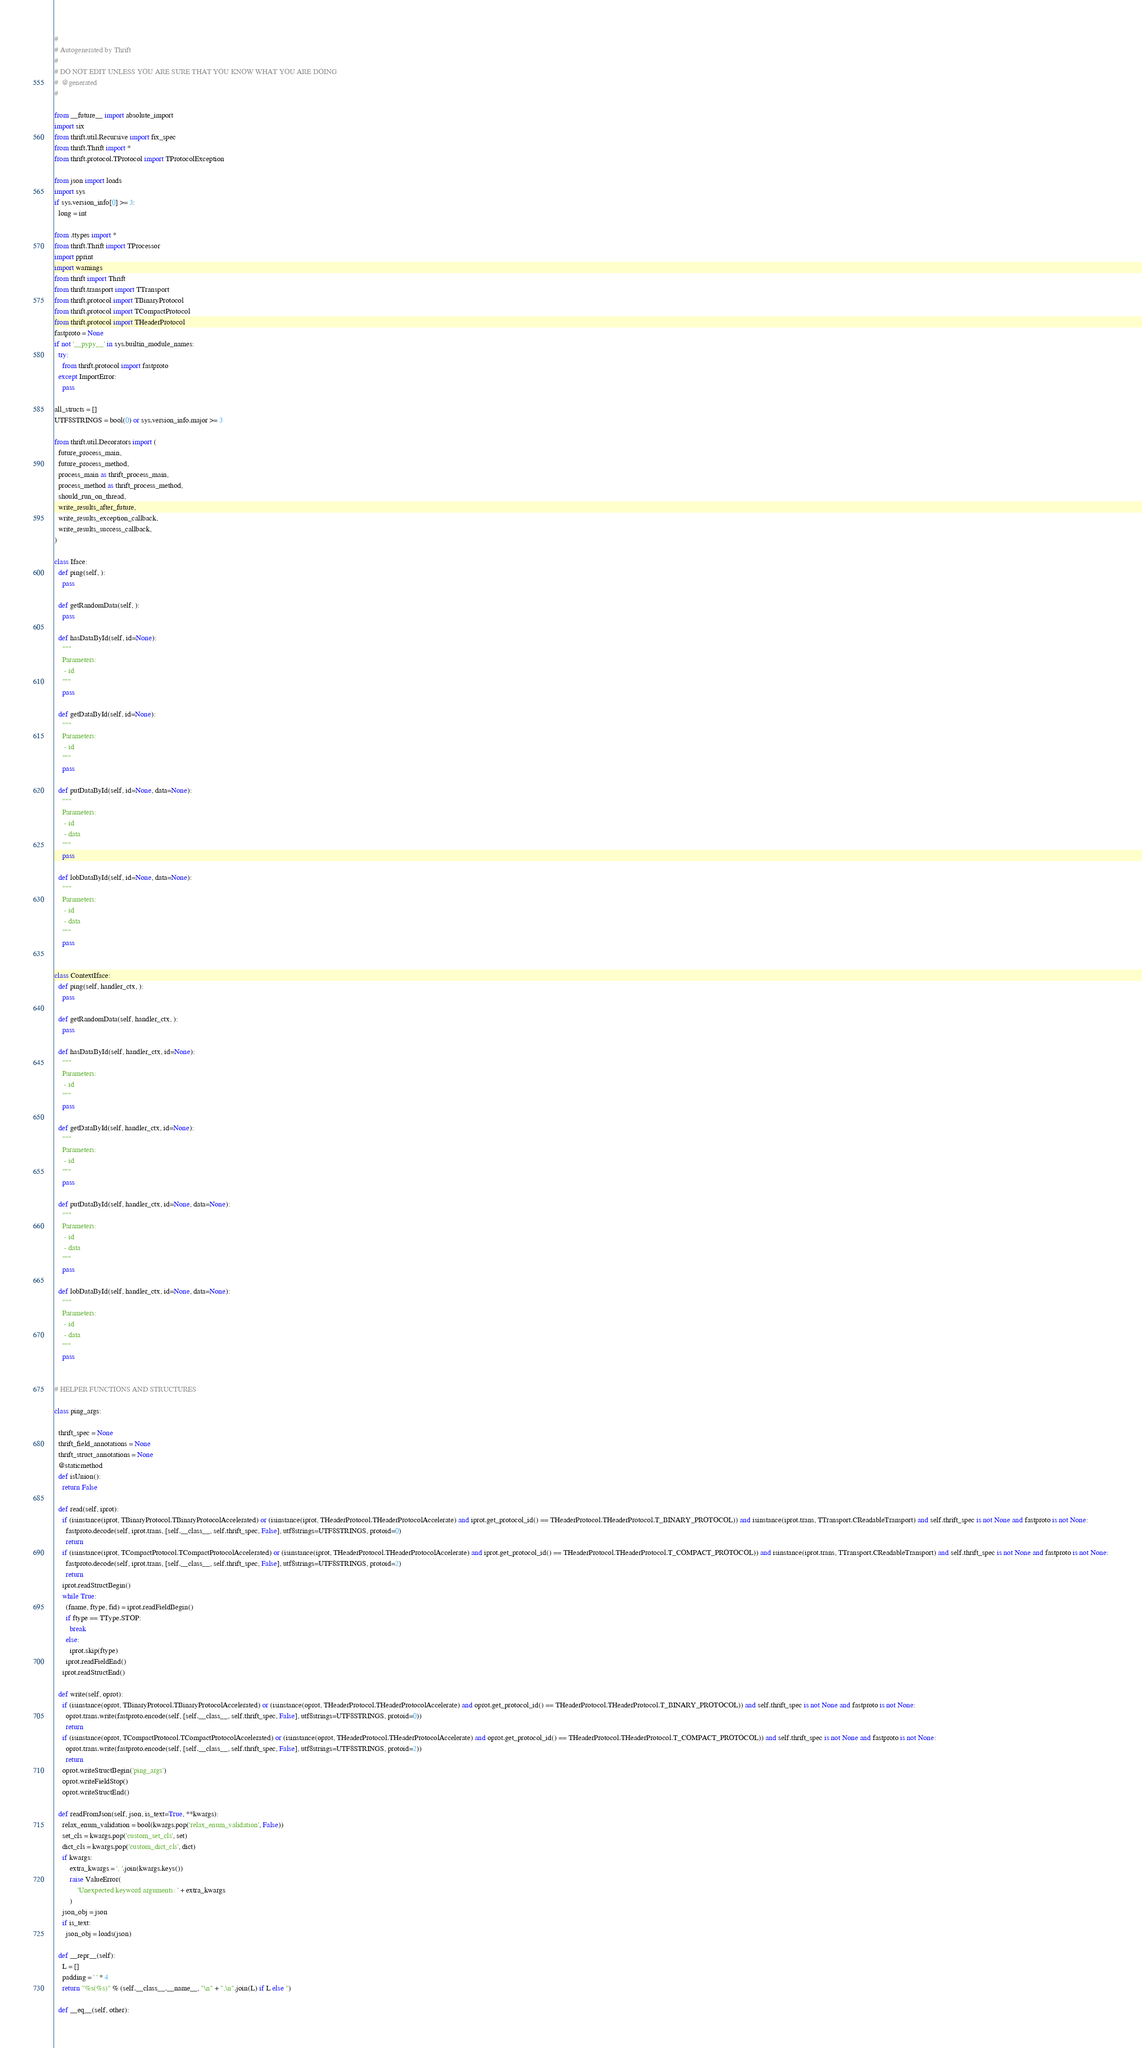Convert code to text. <code><loc_0><loc_0><loc_500><loc_500><_Python_>#
# Autogenerated by Thrift
#
# DO NOT EDIT UNLESS YOU ARE SURE THAT YOU KNOW WHAT YOU ARE DOING
#  @generated
#

from __future__ import absolute_import
import six
from thrift.util.Recursive import fix_spec
from thrift.Thrift import *
from thrift.protocol.TProtocol import TProtocolException

from json import loads
import sys
if sys.version_info[0] >= 3:
  long = int

from .ttypes import *
from thrift.Thrift import TProcessor
import pprint
import warnings
from thrift import Thrift
from thrift.transport import TTransport
from thrift.protocol import TBinaryProtocol
from thrift.protocol import TCompactProtocol
from thrift.protocol import THeaderProtocol
fastproto = None
if not '__pypy__' in sys.builtin_module_names:
  try:
    from thrift.protocol import fastproto
  except ImportError:
    pass

all_structs = []
UTF8STRINGS = bool(0) or sys.version_info.major >= 3

from thrift.util.Decorators import (
  future_process_main,
  future_process_method,
  process_main as thrift_process_main,
  process_method as thrift_process_method,
  should_run_on_thread,
  write_results_after_future,
  write_results_exception_callback,
  write_results_success_callback,
)

class Iface:
  def ping(self, ):
    pass

  def getRandomData(self, ):
    pass

  def hasDataById(self, id=None):
    """
    Parameters:
     - id
    """
    pass

  def getDataById(self, id=None):
    """
    Parameters:
     - id
    """
    pass

  def putDataById(self, id=None, data=None):
    """
    Parameters:
     - id
     - data
    """
    pass

  def lobDataById(self, id=None, data=None):
    """
    Parameters:
     - id
     - data
    """
    pass


class ContextIface:
  def ping(self, handler_ctx, ):
    pass

  def getRandomData(self, handler_ctx, ):
    pass

  def hasDataById(self, handler_ctx, id=None):
    """
    Parameters:
     - id
    """
    pass

  def getDataById(self, handler_ctx, id=None):
    """
    Parameters:
     - id
    """
    pass

  def putDataById(self, handler_ctx, id=None, data=None):
    """
    Parameters:
     - id
     - data
    """
    pass

  def lobDataById(self, handler_ctx, id=None, data=None):
    """
    Parameters:
     - id
     - data
    """
    pass


# HELPER FUNCTIONS AND STRUCTURES

class ping_args:

  thrift_spec = None
  thrift_field_annotations = None
  thrift_struct_annotations = None
  @staticmethod
  def isUnion():
    return False

  def read(self, iprot):
    if (isinstance(iprot, TBinaryProtocol.TBinaryProtocolAccelerated) or (isinstance(iprot, THeaderProtocol.THeaderProtocolAccelerate) and iprot.get_protocol_id() == THeaderProtocol.THeaderProtocol.T_BINARY_PROTOCOL)) and isinstance(iprot.trans, TTransport.CReadableTransport) and self.thrift_spec is not None and fastproto is not None:
      fastproto.decode(self, iprot.trans, [self.__class__, self.thrift_spec, False], utf8strings=UTF8STRINGS, protoid=0)
      return
    if (isinstance(iprot, TCompactProtocol.TCompactProtocolAccelerated) or (isinstance(iprot, THeaderProtocol.THeaderProtocolAccelerate) and iprot.get_protocol_id() == THeaderProtocol.THeaderProtocol.T_COMPACT_PROTOCOL)) and isinstance(iprot.trans, TTransport.CReadableTransport) and self.thrift_spec is not None and fastproto is not None:
      fastproto.decode(self, iprot.trans, [self.__class__, self.thrift_spec, False], utf8strings=UTF8STRINGS, protoid=2)
      return
    iprot.readStructBegin()
    while True:
      (fname, ftype, fid) = iprot.readFieldBegin()
      if ftype == TType.STOP:
        break
      else:
        iprot.skip(ftype)
      iprot.readFieldEnd()
    iprot.readStructEnd()

  def write(self, oprot):
    if (isinstance(oprot, TBinaryProtocol.TBinaryProtocolAccelerated) or (isinstance(oprot, THeaderProtocol.THeaderProtocolAccelerate) and oprot.get_protocol_id() == THeaderProtocol.THeaderProtocol.T_BINARY_PROTOCOL)) and self.thrift_spec is not None and fastproto is not None:
      oprot.trans.write(fastproto.encode(self, [self.__class__, self.thrift_spec, False], utf8strings=UTF8STRINGS, protoid=0))
      return
    if (isinstance(oprot, TCompactProtocol.TCompactProtocolAccelerated) or (isinstance(oprot, THeaderProtocol.THeaderProtocolAccelerate) and oprot.get_protocol_id() == THeaderProtocol.THeaderProtocol.T_COMPACT_PROTOCOL)) and self.thrift_spec is not None and fastproto is not None:
      oprot.trans.write(fastproto.encode(self, [self.__class__, self.thrift_spec, False], utf8strings=UTF8STRINGS, protoid=2))
      return
    oprot.writeStructBegin('ping_args')
    oprot.writeFieldStop()
    oprot.writeStructEnd()

  def readFromJson(self, json, is_text=True, **kwargs):
    relax_enum_validation = bool(kwargs.pop('relax_enum_validation', False))
    set_cls = kwargs.pop('custom_set_cls', set)
    dict_cls = kwargs.pop('custom_dict_cls', dict)
    if kwargs:
        extra_kwargs = ', '.join(kwargs.keys())
        raise ValueError(
            'Unexpected keyword arguments: ' + extra_kwargs
        )
    json_obj = json
    if is_text:
      json_obj = loads(json)

  def __repr__(self):
    L = []
    padding = ' ' * 4
    return "%s(%s)" % (self.__class__.__name__, "\n" + ",\n".join(L) if L else '')

  def __eq__(self, other):</code> 